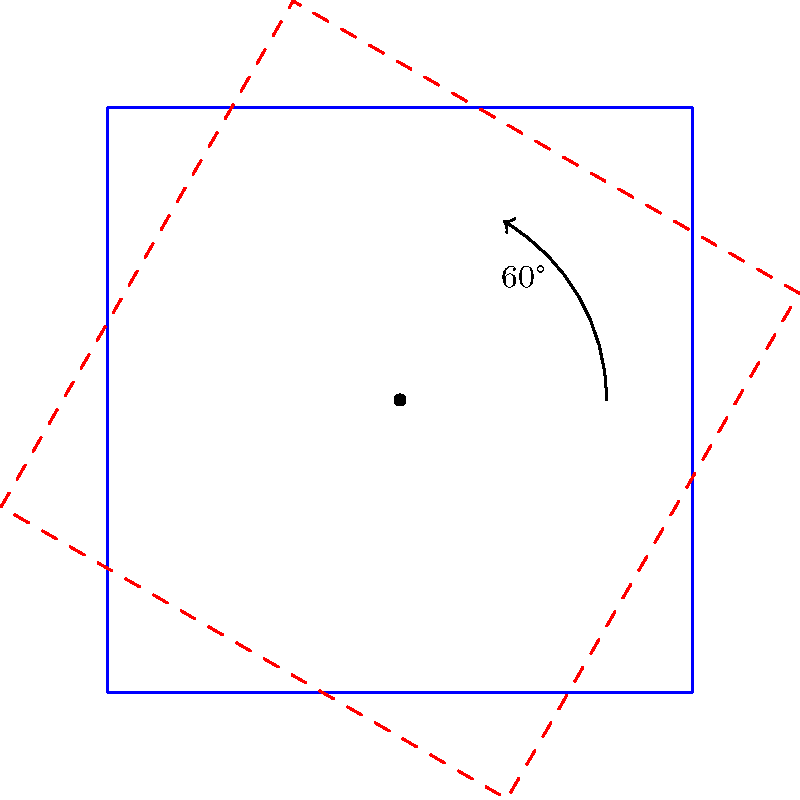A traditional Finnish log cabin, represented by a square, is rotated 60° clockwise around its center point. What is the measure of the smallest angle formed between any side of the original cabin and its corresponding side in the rotated position? To solve this problem, let's follow these steps:

1. Understand the rotation:
   - The cabin (represented by a square) is rotated 60° clockwise.
   - This means each side of the square will be rotated by 60°.

2. Consider the angle between corresponding sides:
   - When a shape is rotated, the angle between any side and its rotated position is equal to the angle of rotation.
   - In this case, that angle is 60°.

3. Analyze the question:
   - We're asked for the smallest angle between any side of the original cabin and its corresponding side in the rotated position.
   - The angle of 60° we found is already the smallest possible angle.

4. Confirm the answer:
   - Any other pair of corresponding sides will also form a 60° angle.
   - Larger angles (e.g., 120°, 180°, 240°, 300°) could be measured between non-corresponding sides, but we're only interested in corresponding sides.

Therefore, the smallest angle formed between any side of the original cabin and its corresponding side in the rotated position is 60°.
Answer: 60° 